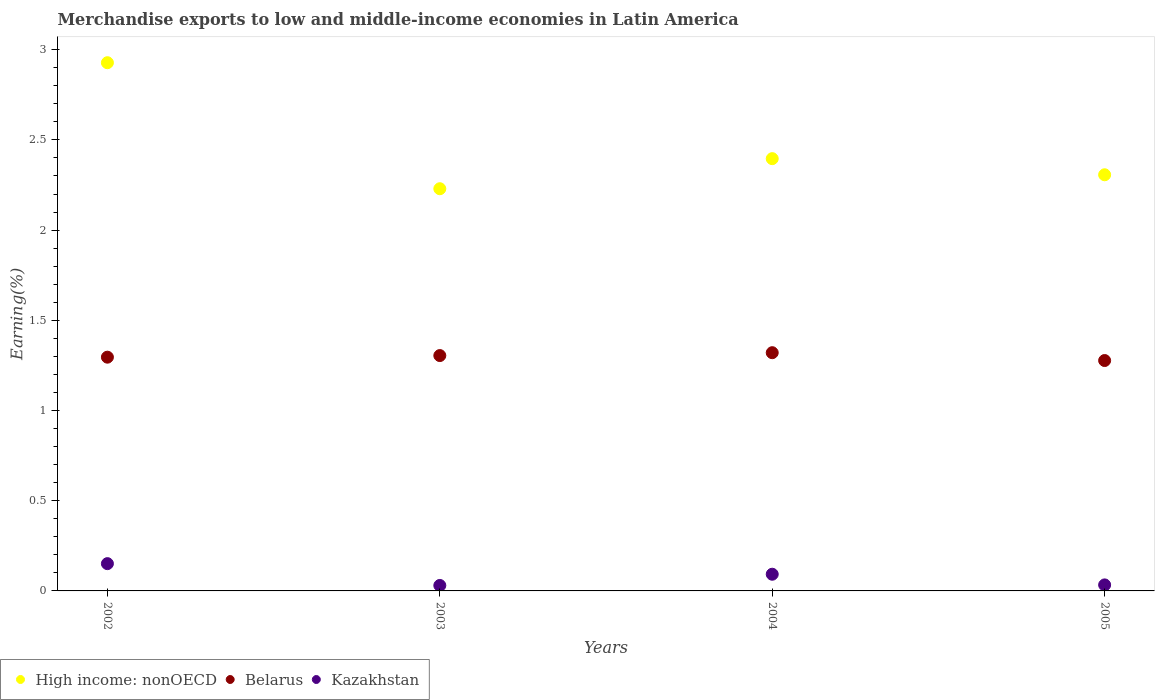How many different coloured dotlines are there?
Provide a short and direct response. 3. What is the percentage of amount earned from merchandise exports in High income: nonOECD in 2004?
Give a very brief answer. 2.4. Across all years, what is the maximum percentage of amount earned from merchandise exports in High income: nonOECD?
Provide a short and direct response. 2.93. Across all years, what is the minimum percentage of amount earned from merchandise exports in Kazakhstan?
Your response must be concise. 0.03. What is the total percentage of amount earned from merchandise exports in Kazakhstan in the graph?
Offer a very short reply. 0.31. What is the difference between the percentage of amount earned from merchandise exports in Belarus in 2002 and that in 2005?
Your answer should be compact. 0.02. What is the difference between the percentage of amount earned from merchandise exports in Kazakhstan in 2004 and the percentage of amount earned from merchandise exports in High income: nonOECD in 2003?
Ensure brevity in your answer.  -2.14. What is the average percentage of amount earned from merchandise exports in Kazakhstan per year?
Provide a succinct answer. 0.08. In the year 2003, what is the difference between the percentage of amount earned from merchandise exports in Belarus and percentage of amount earned from merchandise exports in High income: nonOECD?
Your response must be concise. -0.92. In how many years, is the percentage of amount earned from merchandise exports in Belarus greater than 0.1 %?
Your response must be concise. 4. What is the ratio of the percentage of amount earned from merchandise exports in Kazakhstan in 2003 to that in 2004?
Your response must be concise. 0.33. Is the difference between the percentage of amount earned from merchandise exports in Belarus in 2003 and 2004 greater than the difference between the percentage of amount earned from merchandise exports in High income: nonOECD in 2003 and 2004?
Keep it short and to the point. Yes. What is the difference between the highest and the second highest percentage of amount earned from merchandise exports in High income: nonOECD?
Ensure brevity in your answer.  0.53. What is the difference between the highest and the lowest percentage of amount earned from merchandise exports in Kazakhstan?
Provide a short and direct response. 0.12. In how many years, is the percentage of amount earned from merchandise exports in Belarus greater than the average percentage of amount earned from merchandise exports in Belarus taken over all years?
Make the answer very short. 2. Is the sum of the percentage of amount earned from merchandise exports in High income: nonOECD in 2003 and 2004 greater than the maximum percentage of amount earned from merchandise exports in Belarus across all years?
Provide a short and direct response. Yes. Is it the case that in every year, the sum of the percentage of amount earned from merchandise exports in Belarus and percentage of amount earned from merchandise exports in Kazakhstan  is greater than the percentage of amount earned from merchandise exports in High income: nonOECD?
Provide a short and direct response. No. Is the percentage of amount earned from merchandise exports in High income: nonOECD strictly greater than the percentage of amount earned from merchandise exports in Belarus over the years?
Provide a short and direct response. Yes. Is the percentage of amount earned from merchandise exports in Belarus strictly less than the percentage of amount earned from merchandise exports in High income: nonOECD over the years?
Provide a succinct answer. Yes. How many dotlines are there?
Offer a very short reply. 3. What is the difference between two consecutive major ticks on the Y-axis?
Your response must be concise. 0.5. Does the graph contain any zero values?
Offer a terse response. No. Does the graph contain grids?
Offer a terse response. No. Where does the legend appear in the graph?
Give a very brief answer. Bottom left. How are the legend labels stacked?
Make the answer very short. Horizontal. What is the title of the graph?
Provide a short and direct response. Merchandise exports to low and middle-income economies in Latin America. Does "Gambia, The" appear as one of the legend labels in the graph?
Provide a succinct answer. No. What is the label or title of the Y-axis?
Provide a short and direct response. Earning(%). What is the Earning(%) in High income: nonOECD in 2002?
Ensure brevity in your answer.  2.93. What is the Earning(%) in Belarus in 2002?
Your answer should be very brief. 1.3. What is the Earning(%) of Kazakhstan in 2002?
Offer a terse response. 0.15. What is the Earning(%) in High income: nonOECD in 2003?
Your answer should be compact. 2.23. What is the Earning(%) of Belarus in 2003?
Ensure brevity in your answer.  1.3. What is the Earning(%) in Kazakhstan in 2003?
Your answer should be very brief. 0.03. What is the Earning(%) in High income: nonOECD in 2004?
Give a very brief answer. 2.4. What is the Earning(%) in Belarus in 2004?
Your answer should be compact. 1.32. What is the Earning(%) of Kazakhstan in 2004?
Offer a terse response. 0.09. What is the Earning(%) in High income: nonOECD in 2005?
Provide a succinct answer. 2.31. What is the Earning(%) of Belarus in 2005?
Give a very brief answer. 1.28. What is the Earning(%) in Kazakhstan in 2005?
Provide a short and direct response. 0.03. Across all years, what is the maximum Earning(%) in High income: nonOECD?
Provide a succinct answer. 2.93. Across all years, what is the maximum Earning(%) in Belarus?
Keep it short and to the point. 1.32. Across all years, what is the maximum Earning(%) in Kazakhstan?
Make the answer very short. 0.15. Across all years, what is the minimum Earning(%) in High income: nonOECD?
Offer a terse response. 2.23. Across all years, what is the minimum Earning(%) in Belarus?
Your answer should be very brief. 1.28. Across all years, what is the minimum Earning(%) in Kazakhstan?
Provide a short and direct response. 0.03. What is the total Earning(%) of High income: nonOECD in the graph?
Keep it short and to the point. 9.86. What is the total Earning(%) of Belarus in the graph?
Keep it short and to the point. 5.2. What is the total Earning(%) in Kazakhstan in the graph?
Your answer should be compact. 0.31. What is the difference between the Earning(%) in High income: nonOECD in 2002 and that in 2003?
Offer a very short reply. 0.7. What is the difference between the Earning(%) in Belarus in 2002 and that in 2003?
Your answer should be compact. -0.01. What is the difference between the Earning(%) in Kazakhstan in 2002 and that in 2003?
Offer a terse response. 0.12. What is the difference between the Earning(%) of High income: nonOECD in 2002 and that in 2004?
Your answer should be very brief. 0.53. What is the difference between the Earning(%) of Belarus in 2002 and that in 2004?
Your response must be concise. -0.02. What is the difference between the Earning(%) of Kazakhstan in 2002 and that in 2004?
Offer a very short reply. 0.06. What is the difference between the Earning(%) in High income: nonOECD in 2002 and that in 2005?
Ensure brevity in your answer.  0.62. What is the difference between the Earning(%) of Belarus in 2002 and that in 2005?
Offer a terse response. 0.02. What is the difference between the Earning(%) in Kazakhstan in 2002 and that in 2005?
Keep it short and to the point. 0.12. What is the difference between the Earning(%) in High income: nonOECD in 2003 and that in 2004?
Make the answer very short. -0.17. What is the difference between the Earning(%) in Belarus in 2003 and that in 2004?
Offer a terse response. -0.02. What is the difference between the Earning(%) in Kazakhstan in 2003 and that in 2004?
Offer a terse response. -0.06. What is the difference between the Earning(%) of High income: nonOECD in 2003 and that in 2005?
Your answer should be compact. -0.08. What is the difference between the Earning(%) of Belarus in 2003 and that in 2005?
Give a very brief answer. 0.03. What is the difference between the Earning(%) in Kazakhstan in 2003 and that in 2005?
Offer a terse response. -0. What is the difference between the Earning(%) in High income: nonOECD in 2004 and that in 2005?
Make the answer very short. 0.09. What is the difference between the Earning(%) of Belarus in 2004 and that in 2005?
Your answer should be very brief. 0.04. What is the difference between the Earning(%) of Kazakhstan in 2004 and that in 2005?
Your response must be concise. 0.06. What is the difference between the Earning(%) in High income: nonOECD in 2002 and the Earning(%) in Belarus in 2003?
Provide a succinct answer. 1.62. What is the difference between the Earning(%) in High income: nonOECD in 2002 and the Earning(%) in Kazakhstan in 2003?
Ensure brevity in your answer.  2.9. What is the difference between the Earning(%) in Belarus in 2002 and the Earning(%) in Kazakhstan in 2003?
Your answer should be compact. 1.27. What is the difference between the Earning(%) in High income: nonOECD in 2002 and the Earning(%) in Belarus in 2004?
Keep it short and to the point. 1.61. What is the difference between the Earning(%) of High income: nonOECD in 2002 and the Earning(%) of Kazakhstan in 2004?
Offer a very short reply. 2.84. What is the difference between the Earning(%) in Belarus in 2002 and the Earning(%) in Kazakhstan in 2004?
Ensure brevity in your answer.  1.2. What is the difference between the Earning(%) in High income: nonOECD in 2002 and the Earning(%) in Belarus in 2005?
Ensure brevity in your answer.  1.65. What is the difference between the Earning(%) in High income: nonOECD in 2002 and the Earning(%) in Kazakhstan in 2005?
Provide a succinct answer. 2.89. What is the difference between the Earning(%) of Belarus in 2002 and the Earning(%) of Kazakhstan in 2005?
Keep it short and to the point. 1.26. What is the difference between the Earning(%) in High income: nonOECD in 2003 and the Earning(%) in Belarus in 2004?
Your response must be concise. 0.91. What is the difference between the Earning(%) of High income: nonOECD in 2003 and the Earning(%) of Kazakhstan in 2004?
Give a very brief answer. 2.14. What is the difference between the Earning(%) of Belarus in 2003 and the Earning(%) of Kazakhstan in 2004?
Your answer should be very brief. 1.21. What is the difference between the Earning(%) of High income: nonOECD in 2003 and the Earning(%) of Belarus in 2005?
Your response must be concise. 0.95. What is the difference between the Earning(%) in High income: nonOECD in 2003 and the Earning(%) in Kazakhstan in 2005?
Your response must be concise. 2.2. What is the difference between the Earning(%) of Belarus in 2003 and the Earning(%) of Kazakhstan in 2005?
Make the answer very short. 1.27. What is the difference between the Earning(%) in High income: nonOECD in 2004 and the Earning(%) in Belarus in 2005?
Ensure brevity in your answer.  1.12. What is the difference between the Earning(%) in High income: nonOECD in 2004 and the Earning(%) in Kazakhstan in 2005?
Ensure brevity in your answer.  2.36. What is the difference between the Earning(%) of Belarus in 2004 and the Earning(%) of Kazakhstan in 2005?
Your answer should be compact. 1.29. What is the average Earning(%) in High income: nonOECD per year?
Provide a succinct answer. 2.46. What is the average Earning(%) of Belarus per year?
Ensure brevity in your answer.  1.3. What is the average Earning(%) of Kazakhstan per year?
Provide a short and direct response. 0.08. In the year 2002, what is the difference between the Earning(%) in High income: nonOECD and Earning(%) in Belarus?
Your answer should be very brief. 1.63. In the year 2002, what is the difference between the Earning(%) of High income: nonOECD and Earning(%) of Kazakhstan?
Keep it short and to the point. 2.78. In the year 2002, what is the difference between the Earning(%) in Belarus and Earning(%) in Kazakhstan?
Make the answer very short. 1.14. In the year 2003, what is the difference between the Earning(%) of High income: nonOECD and Earning(%) of Belarus?
Provide a succinct answer. 0.92. In the year 2003, what is the difference between the Earning(%) in High income: nonOECD and Earning(%) in Kazakhstan?
Ensure brevity in your answer.  2.2. In the year 2003, what is the difference between the Earning(%) of Belarus and Earning(%) of Kazakhstan?
Offer a terse response. 1.27. In the year 2004, what is the difference between the Earning(%) of High income: nonOECD and Earning(%) of Belarus?
Offer a very short reply. 1.08. In the year 2004, what is the difference between the Earning(%) of High income: nonOECD and Earning(%) of Kazakhstan?
Give a very brief answer. 2.3. In the year 2004, what is the difference between the Earning(%) in Belarus and Earning(%) in Kazakhstan?
Your answer should be very brief. 1.23. In the year 2005, what is the difference between the Earning(%) in High income: nonOECD and Earning(%) in Belarus?
Ensure brevity in your answer.  1.03. In the year 2005, what is the difference between the Earning(%) in High income: nonOECD and Earning(%) in Kazakhstan?
Ensure brevity in your answer.  2.27. In the year 2005, what is the difference between the Earning(%) of Belarus and Earning(%) of Kazakhstan?
Offer a terse response. 1.24. What is the ratio of the Earning(%) of High income: nonOECD in 2002 to that in 2003?
Make the answer very short. 1.31. What is the ratio of the Earning(%) in Kazakhstan in 2002 to that in 2003?
Your response must be concise. 4.99. What is the ratio of the Earning(%) in High income: nonOECD in 2002 to that in 2004?
Provide a short and direct response. 1.22. What is the ratio of the Earning(%) of Belarus in 2002 to that in 2004?
Provide a succinct answer. 0.98. What is the ratio of the Earning(%) of Kazakhstan in 2002 to that in 2004?
Your answer should be very brief. 1.63. What is the ratio of the Earning(%) in High income: nonOECD in 2002 to that in 2005?
Your answer should be compact. 1.27. What is the ratio of the Earning(%) of Belarus in 2002 to that in 2005?
Make the answer very short. 1.01. What is the ratio of the Earning(%) of Kazakhstan in 2002 to that in 2005?
Offer a very short reply. 4.53. What is the ratio of the Earning(%) in High income: nonOECD in 2003 to that in 2004?
Make the answer very short. 0.93. What is the ratio of the Earning(%) in Belarus in 2003 to that in 2004?
Give a very brief answer. 0.99. What is the ratio of the Earning(%) in Kazakhstan in 2003 to that in 2004?
Give a very brief answer. 0.33. What is the ratio of the Earning(%) of High income: nonOECD in 2003 to that in 2005?
Provide a succinct answer. 0.97. What is the ratio of the Earning(%) of Belarus in 2003 to that in 2005?
Provide a succinct answer. 1.02. What is the ratio of the Earning(%) in Kazakhstan in 2003 to that in 2005?
Give a very brief answer. 0.91. What is the ratio of the Earning(%) of High income: nonOECD in 2004 to that in 2005?
Provide a succinct answer. 1.04. What is the ratio of the Earning(%) of Belarus in 2004 to that in 2005?
Your answer should be compact. 1.03. What is the ratio of the Earning(%) of Kazakhstan in 2004 to that in 2005?
Keep it short and to the point. 2.77. What is the difference between the highest and the second highest Earning(%) of High income: nonOECD?
Offer a very short reply. 0.53. What is the difference between the highest and the second highest Earning(%) of Belarus?
Provide a succinct answer. 0.02. What is the difference between the highest and the second highest Earning(%) in Kazakhstan?
Your response must be concise. 0.06. What is the difference between the highest and the lowest Earning(%) of High income: nonOECD?
Give a very brief answer. 0.7. What is the difference between the highest and the lowest Earning(%) in Belarus?
Provide a short and direct response. 0.04. What is the difference between the highest and the lowest Earning(%) of Kazakhstan?
Ensure brevity in your answer.  0.12. 